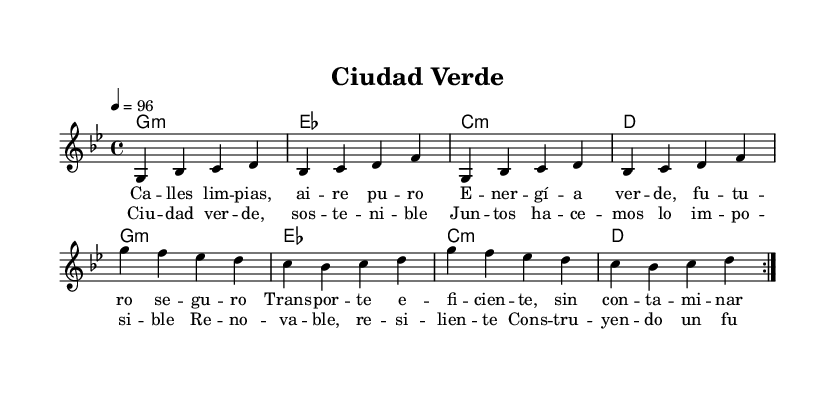What is the key signature of this music? The key signature indicated in the first part of the music is G minor, which is represented by two flats.
Answer: G minor What is the time signature of the piece? The time signature shown at the beginning is 4/4, indicating four beats per measure.
Answer: 4/4 What is the tempo marking given in the music? The tempo marking specifies a speed of 96 beats per minute, indicated by "4 = 96" at the beginning of the score.
Answer: 96 How many times does the melody repeat in this piece? The melody is marked to repeat twice, as indicated by the "repeat volta 2" instructions in the score.
Answer: Twice What type of chords are predominantly used in this piece? The chords listed are mostly minor, as indicated by the chord symbols like "g1:m" (G minor) and "c:m" (C minor).
Answer: Minor Which line contains lyrics related to urban sustainability? The lyrics in the verses specifically address themes of clean streets, pure air, and sustainable energy.
Answer: Verse One What is the thematic focus of the chorus? The chorus emphasizes sustainable development and renewable energy, suggesting a vision for a resilient future.
Answer: Sustainable development 